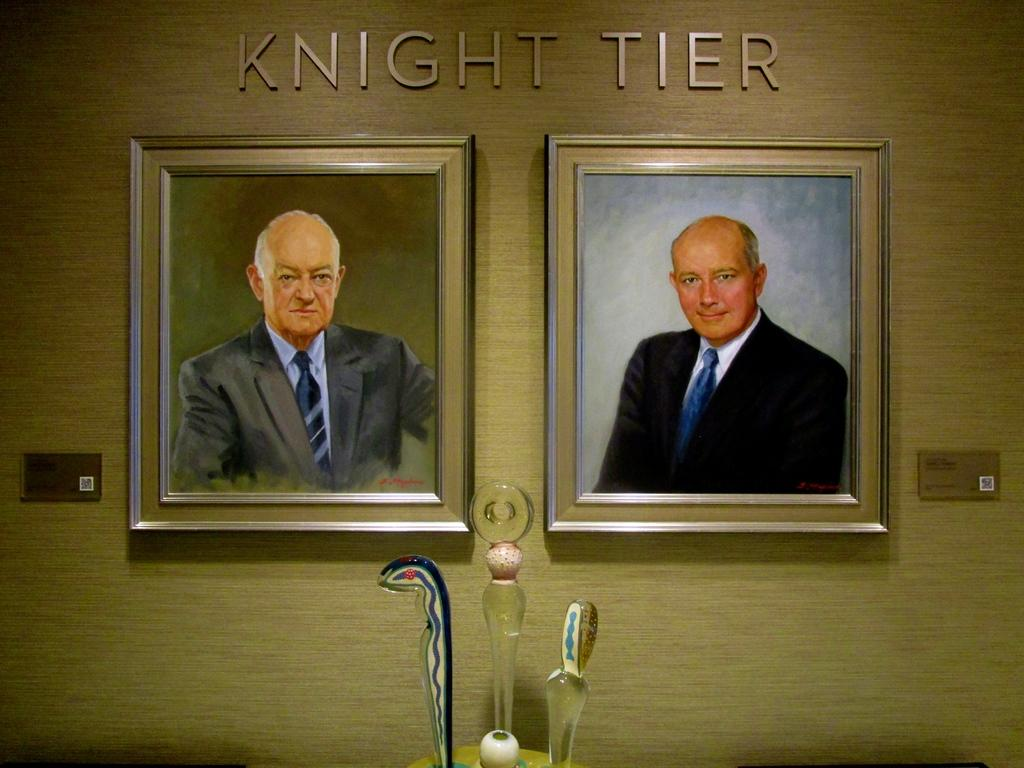<image>
Present a compact description of the photo's key features. A display on a wall called Knight Tier has two framed pictures of men in suits. 